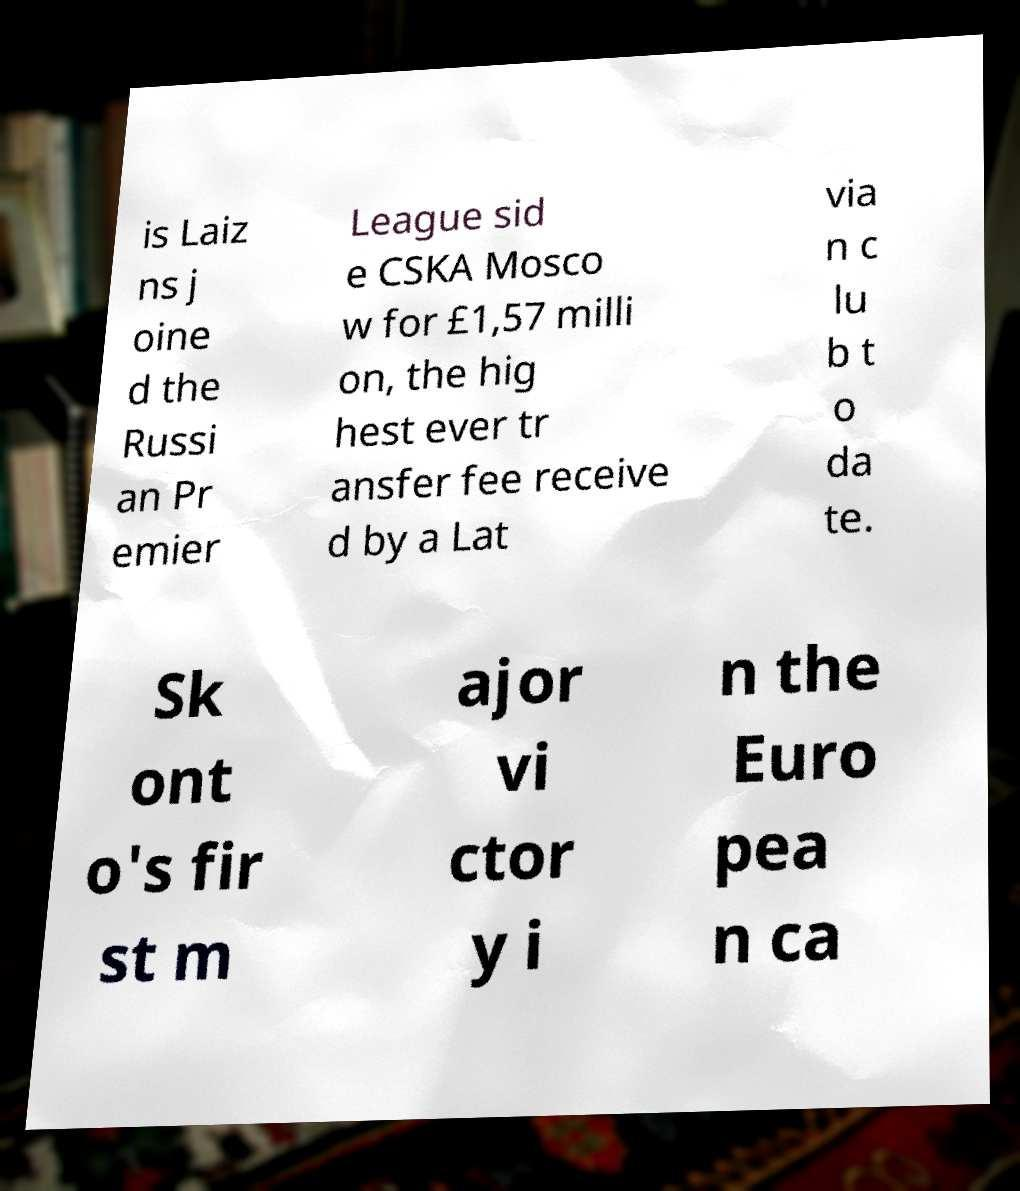Can you accurately transcribe the text from the provided image for me? is Laiz ns j oine d the Russi an Pr emier League sid e CSKA Mosco w for £1,57 milli on, the hig hest ever tr ansfer fee receive d by a Lat via n c lu b t o da te. Sk ont o's fir st m ajor vi ctor y i n the Euro pea n ca 